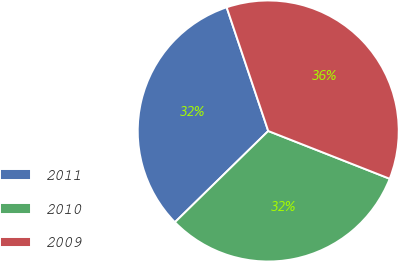Convert chart to OTSL. <chart><loc_0><loc_0><loc_500><loc_500><pie_chart><fcel>2011<fcel>2010<fcel>2009<nl><fcel>32.16%<fcel>31.72%<fcel>36.13%<nl></chart> 